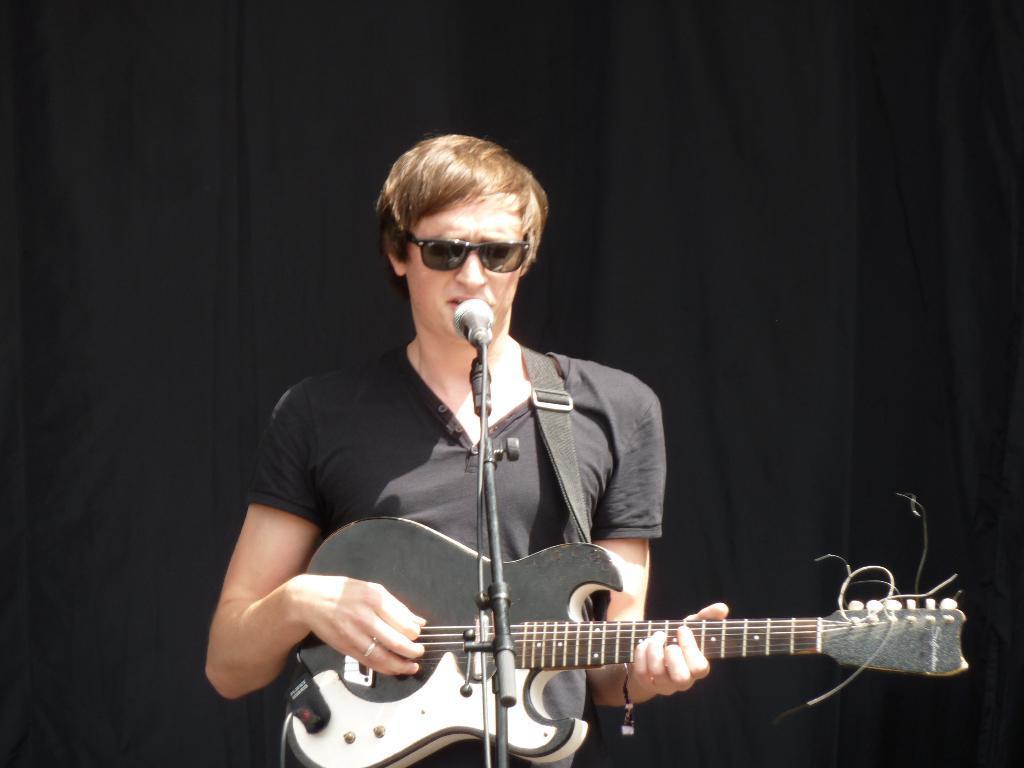Please provide a concise description of this image. In this image we can see a person is standing and playing the guitar and singing, and in front here is the microphone and stand. 